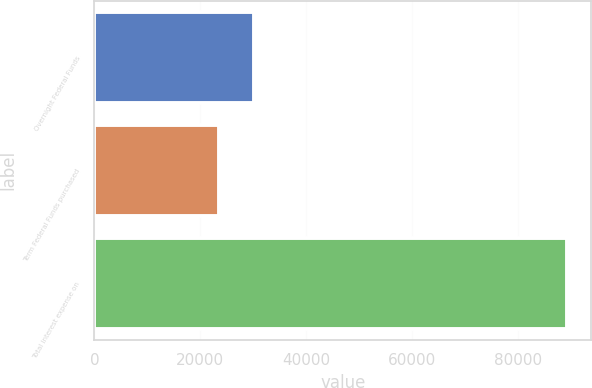<chart> <loc_0><loc_0><loc_500><loc_500><bar_chart><fcel>Overnight Federal Funds<fcel>Term Federal Funds purchased<fcel>Total interest expense on<nl><fcel>30048.6<fcel>23463<fcel>89319<nl></chart> 